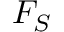Convert formula to latex. <formula><loc_0><loc_0><loc_500><loc_500>F _ { S }</formula> 